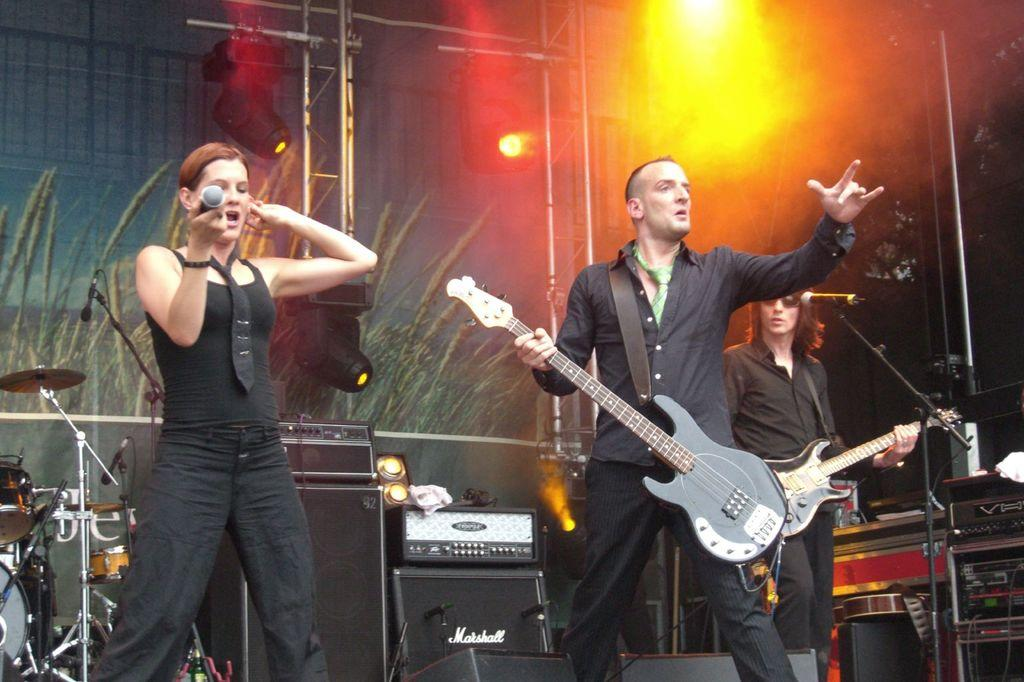What are the people in the image doing? The people in the image are holding musical instruments. What else can be seen in the image besides the people and their instruments? There are stands and lights visible in the image. What type of feather can be seen on the square farm in the image? There is no feather or farm present in the image; it features people holding musical instruments, stands, and lights. 